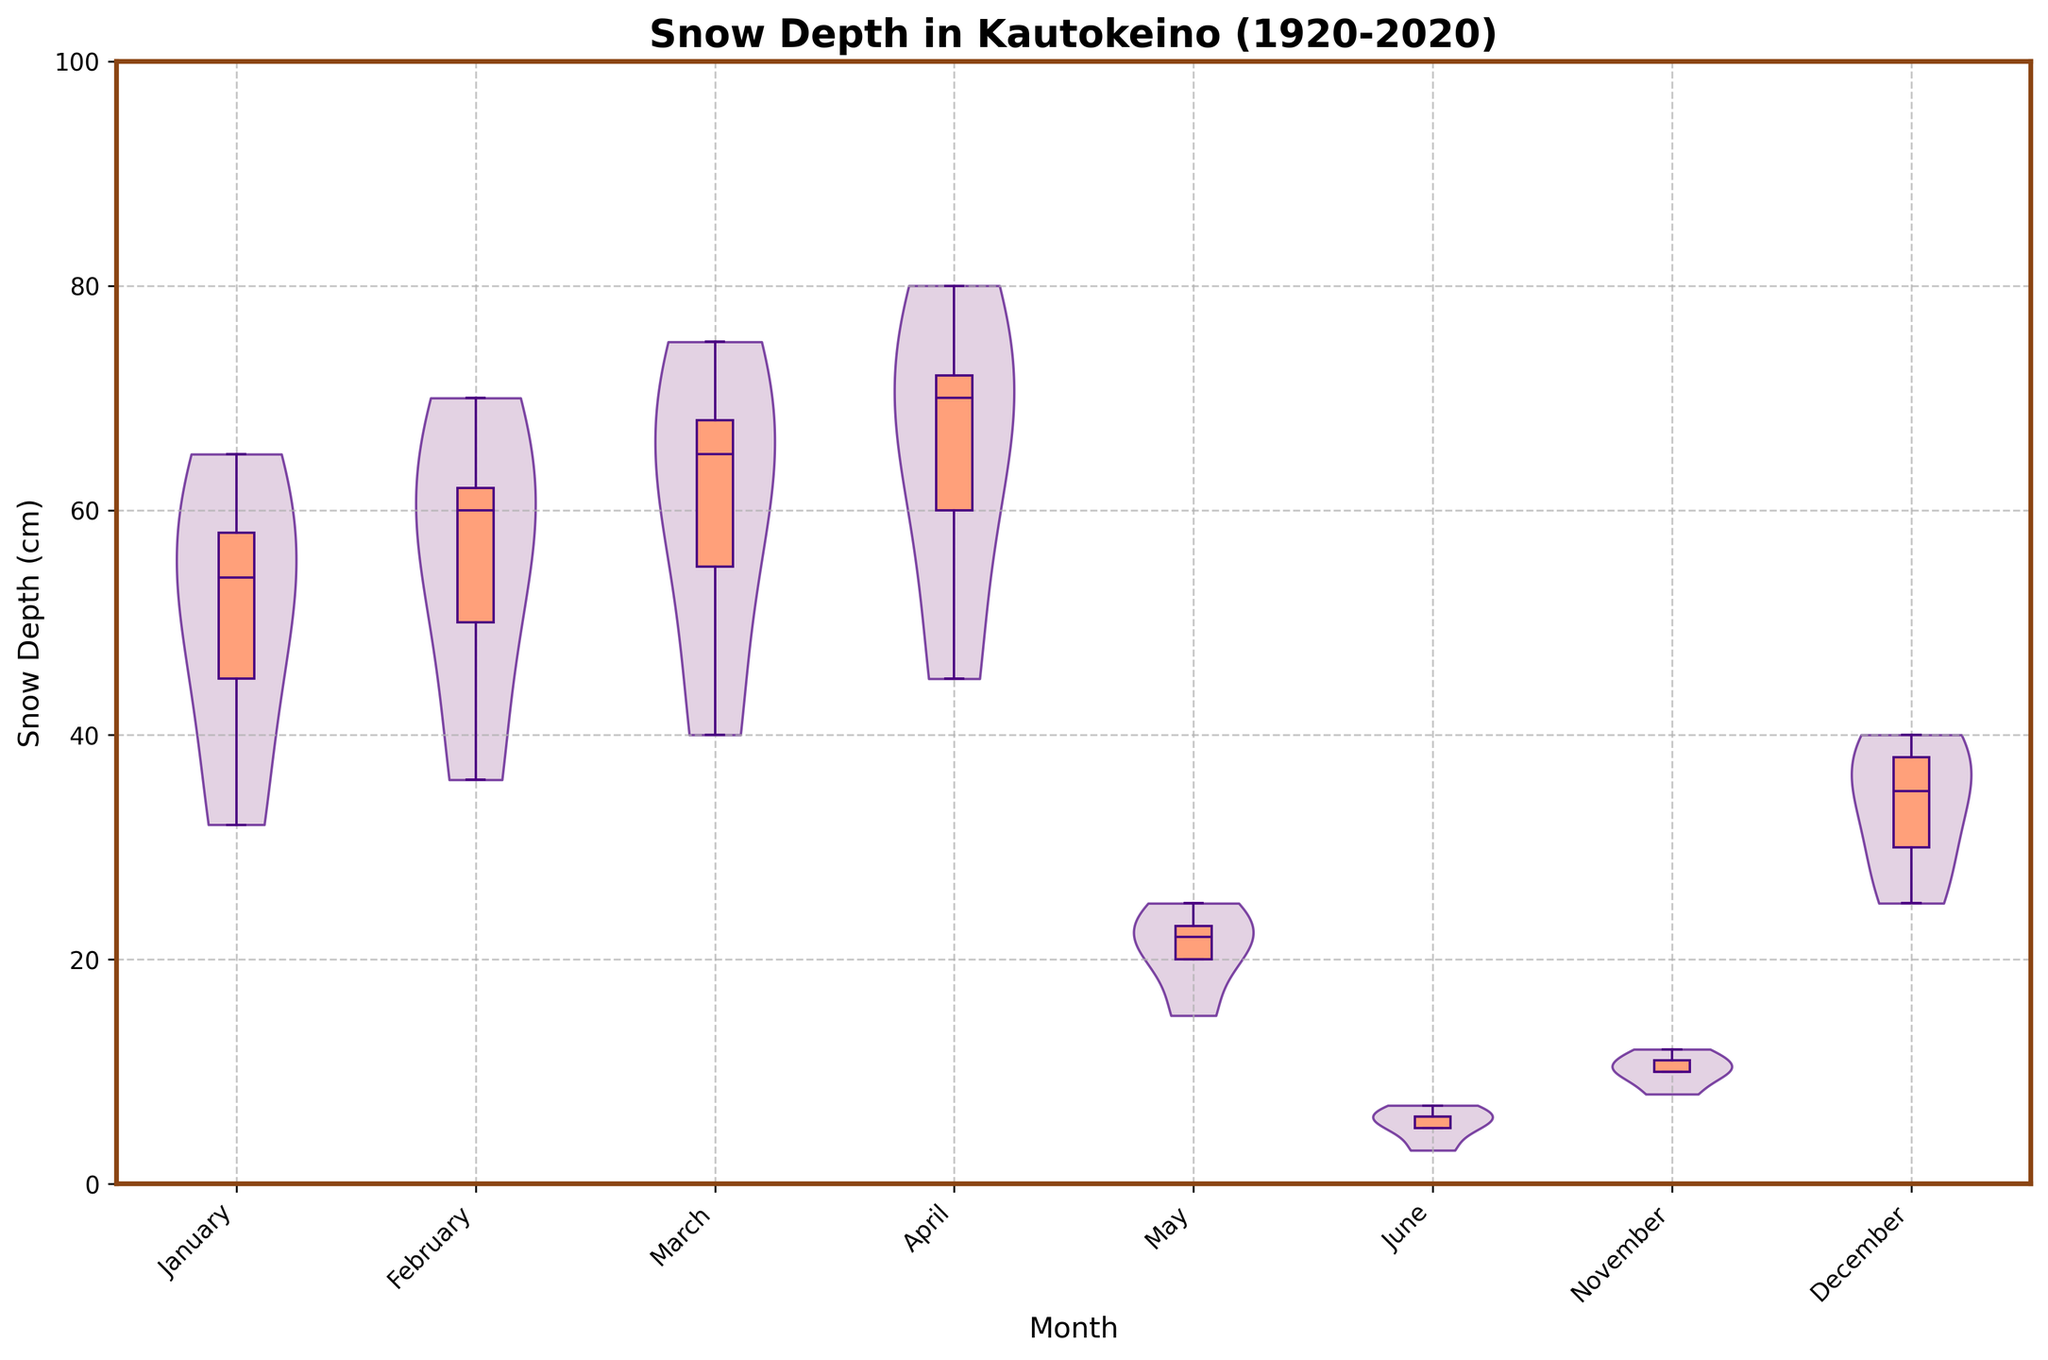What is the title of the chart? The title of the chart is located at the top of the graph.
Answer: Snow Depth in Kautokeino (1920-2020) What does the y-axis represent? The y-axis represents the snow depth measured in centimeters.
Answer: Snow Depth (cm) Which month shows the highest median snow depth over the past century? The median is located in the central line of each box in the violin plot. The highest median value corresponds to March.
Answer: March Which month shows the lowest median snow depth over the past century? The lowest median value is observed in June. The central line of the box plot is closest to the bottom end of the y-axis.
Answer: June How has the snow depth in January varied over the years? The violin plot for January has a wider spread from 30 cm to 65 cm, indicating significant variation in snow depth over the years.
Answer: 30 cm to 65 cm What is the interquartile range (IQR) for snow depth in February? The IQR is the difference between the third quartile (top edge of the box) and the first quartile (bottom edge of the box). For February, this range is approximately from 50 cm to 62 cm, so the IQR is 62 - 50 = 12 cm.
Answer: 12 cm Which month has the widest distribution of snow depth? The width of the violin plot shows the distribution. April has the widest distribution as indicated by the broad spread of the violin plot.
Answer: April Is the median snow depth in April higher than the mean snow depth in December? By looking at the relative position of the central line in April's box plot and comparing it to the average position of the distribution in December's violin plot, it is observable that April's median is higher.
Answer: Yes Compare the spread of the snow depth in November and December. Which month shows more variation? The spread of the violin plot represents variation. November has a narrower spread compared to December, indicating less variation.
Answer: December How do the whiskers of the box plot in March compare to those in January? The whiskers extend from the quartiles to the min and max values. March whiskers are longer than January ones, indicating a greater range of snow depth values in March.
Answer: March 